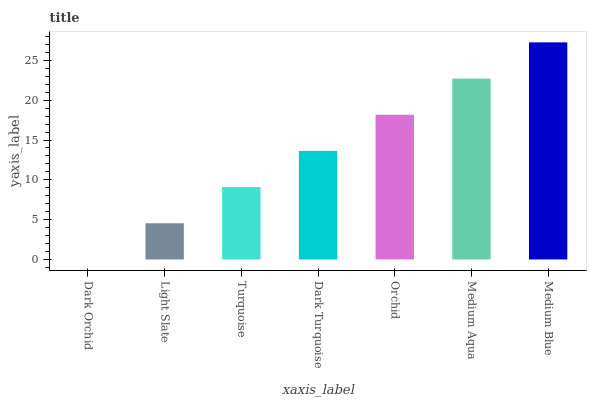Is Dark Orchid the minimum?
Answer yes or no. Yes. Is Medium Blue the maximum?
Answer yes or no. Yes. Is Light Slate the minimum?
Answer yes or no. No. Is Light Slate the maximum?
Answer yes or no. No. Is Light Slate greater than Dark Orchid?
Answer yes or no. Yes. Is Dark Orchid less than Light Slate?
Answer yes or no. Yes. Is Dark Orchid greater than Light Slate?
Answer yes or no. No. Is Light Slate less than Dark Orchid?
Answer yes or no. No. Is Dark Turquoise the high median?
Answer yes or no. Yes. Is Dark Turquoise the low median?
Answer yes or no. Yes. Is Medium Aqua the high median?
Answer yes or no. No. Is Light Slate the low median?
Answer yes or no. No. 